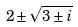<formula> <loc_0><loc_0><loc_500><loc_500>2 \pm \sqrt { 3 \pm i }</formula> 